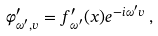Convert formula to latex. <formula><loc_0><loc_0><loc_500><loc_500>\varphi ^ { \prime } _ { \omega ^ { \prime } , v } = f ^ { \prime } _ { \omega ^ { \prime } } ( x ) e ^ { - i \omega ^ { \prime } v } \, ,</formula> 